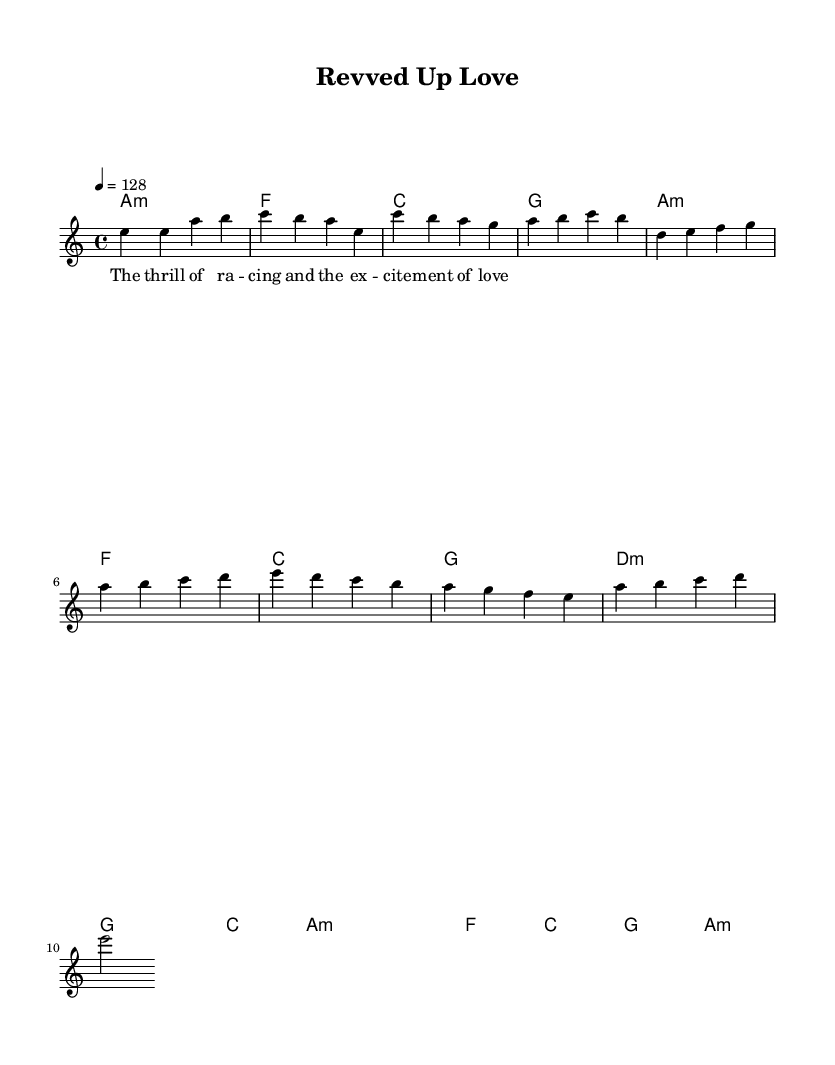What is the key signature of this music? The key signature is A minor, which is indicated by the absence of any sharps or flats and aligns with the A minor scale.
Answer: A minor What is the time signature of this music? The time signature is 4/4, which is represented at the beginning of the score and indicates four beats per measure.
Answer: 4/4 What is the tempo marking of this piece? The tempo marking indicates a speed of 128 beats per minute, which is specified at the beginning of the score with the notation "4 = 128."
Answer: 128 What chord progresses during the pre-chorus? The pre-chorus consists of the following chord progression: D minor, G major, C major, A minor, derived from observing the chord changes listed for that section of the score.
Answer: D minor, G major, C major, A minor What is the first note of the melody? The first note of the melody is E, which is found at the beginning of the melody line in the introductory measures.
Answer: E What are the placeholder lyrics for the chorus? The placeholder lyrics for the chorus are "The thrill of ra -- cing and the ex -- cite -- ment of love," as indicated beneath the melody line in the lyrics section.
Answer: The thrill of ra -- cing and the ex -- cite -- ment of love 